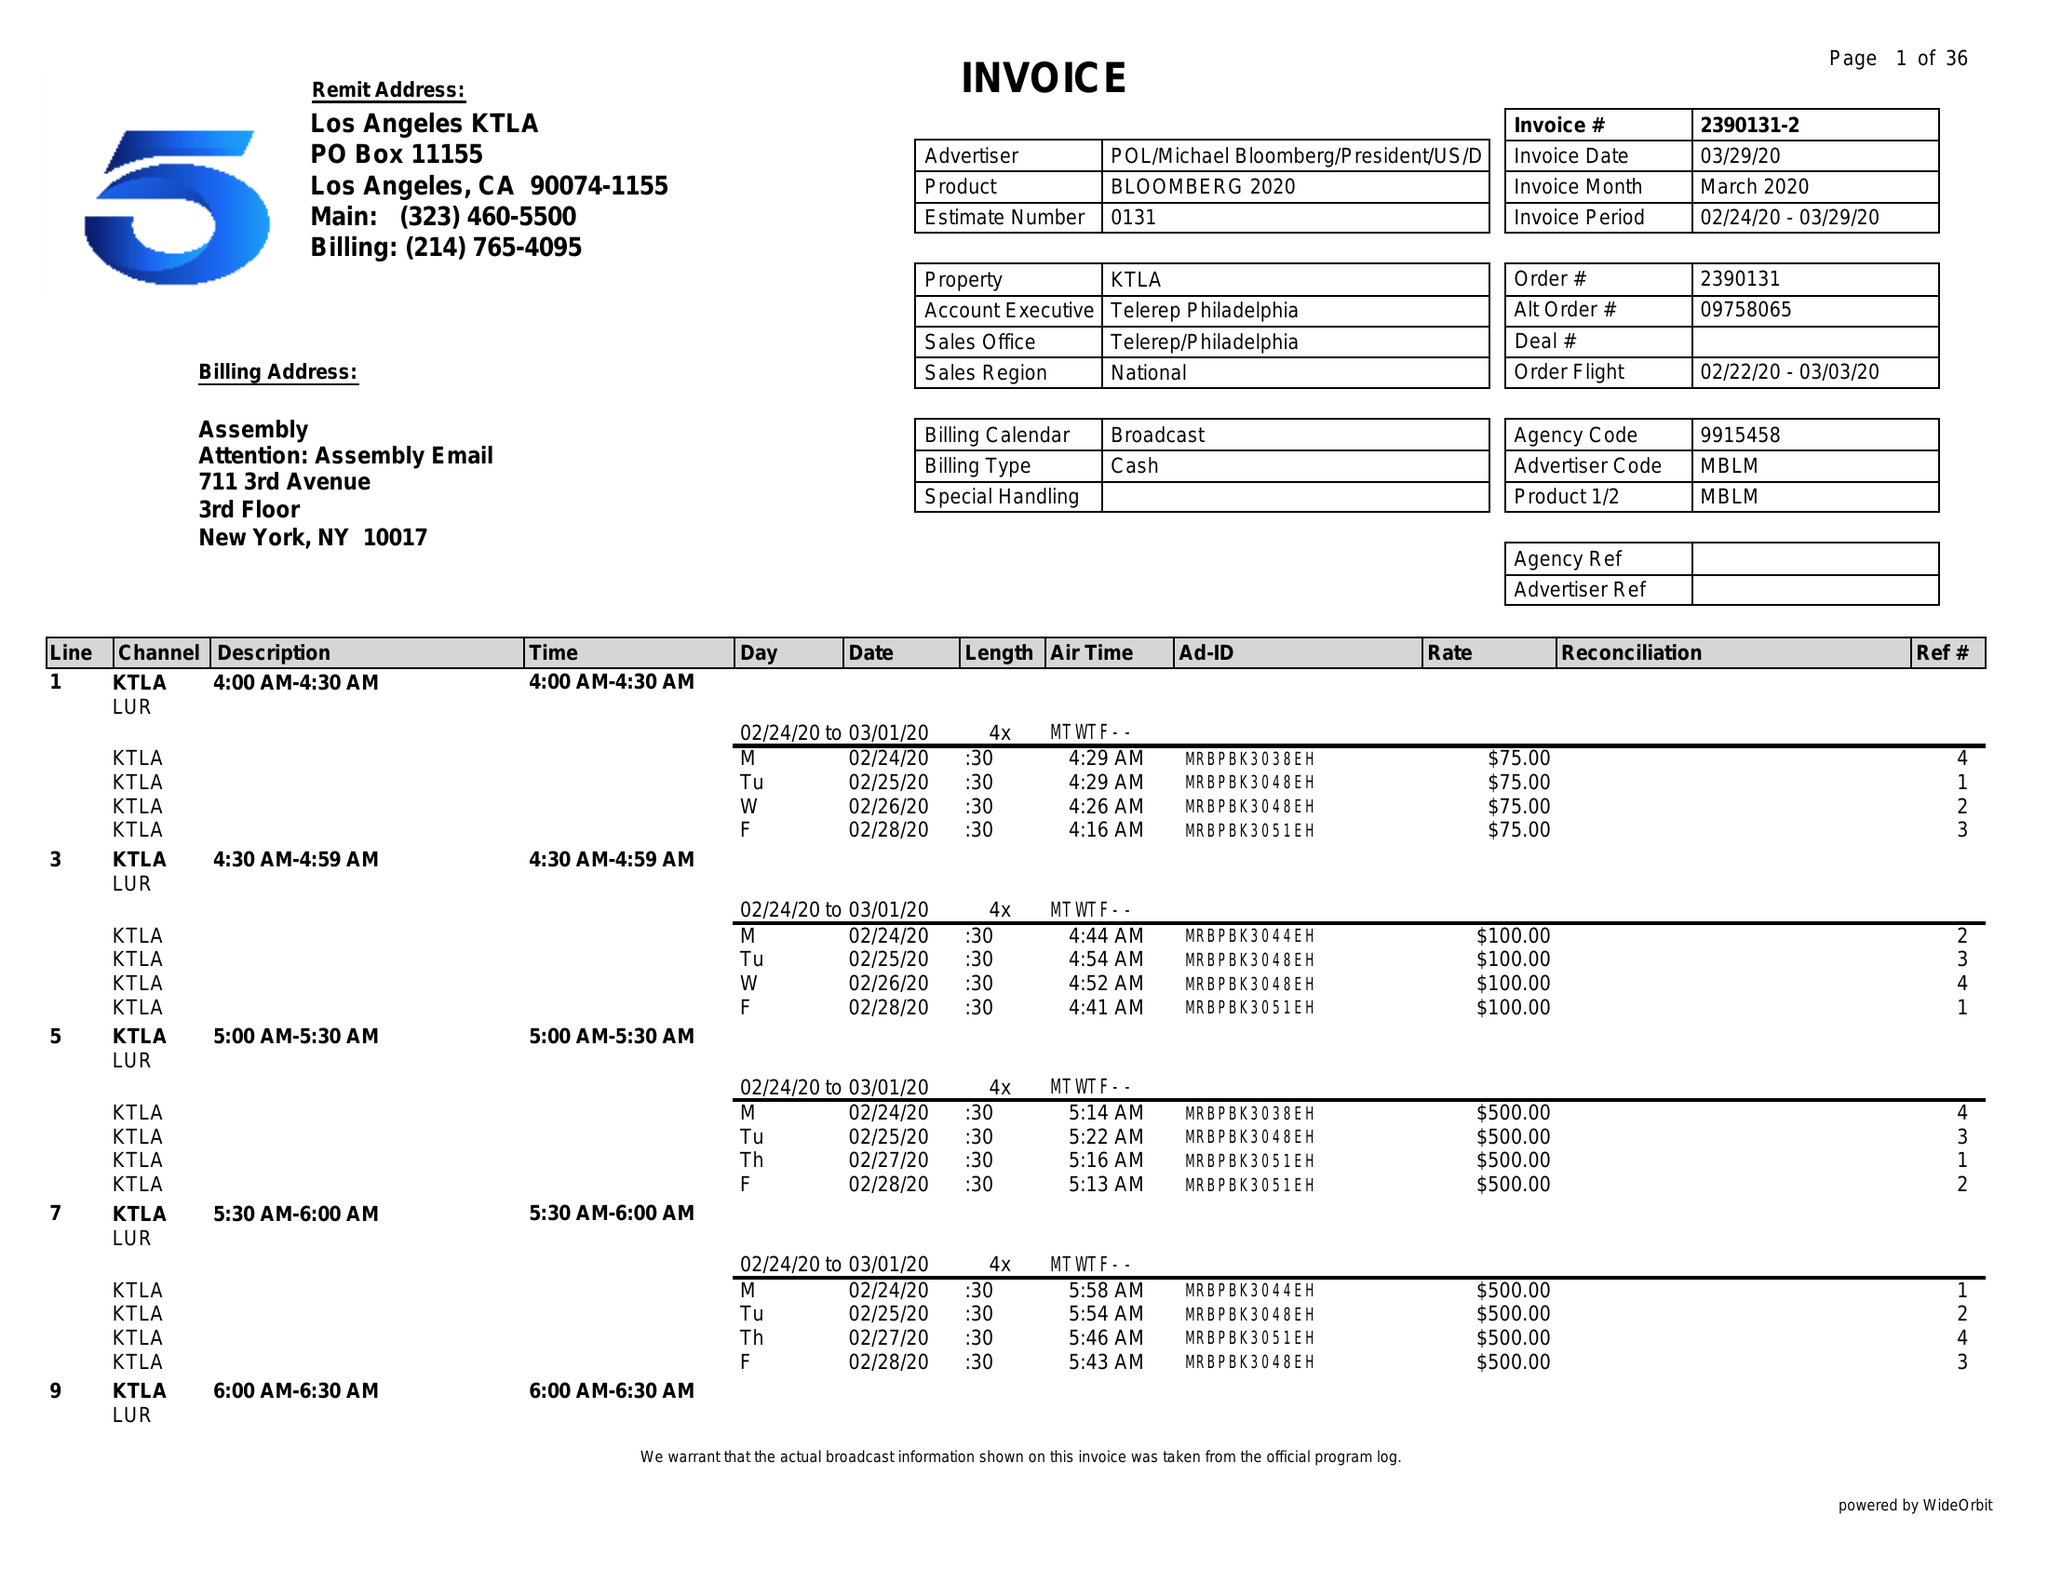What is the value for the gross_amount?
Answer the question using a single word or phrase. 496425.00 